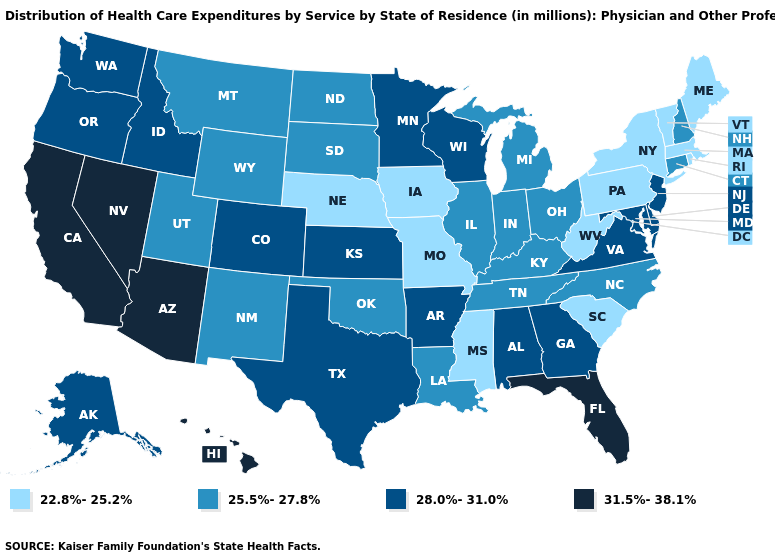Which states have the highest value in the USA?
Quick response, please. Arizona, California, Florida, Hawaii, Nevada. Does New Mexico have a higher value than Oklahoma?
Short answer required. No. What is the value of Oklahoma?
Answer briefly. 25.5%-27.8%. Does Pennsylvania have the highest value in the USA?
Answer briefly. No. Name the states that have a value in the range 22.8%-25.2%?
Short answer required. Iowa, Maine, Massachusetts, Mississippi, Missouri, Nebraska, New York, Pennsylvania, Rhode Island, South Carolina, Vermont, West Virginia. What is the value of Washington?
Keep it brief. 28.0%-31.0%. Among the states that border Minnesota , which have the lowest value?
Be succinct. Iowa. Name the states that have a value in the range 31.5%-38.1%?
Quick response, please. Arizona, California, Florida, Hawaii, Nevada. What is the value of Illinois?
Keep it brief. 25.5%-27.8%. Name the states that have a value in the range 25.5%-27.8%?
Keep it brief. Connecticut, Illinois, Indiana, Kentucky, Louisiana, Michigan, Montana, New Hampshire, New Mexico, North Carolina, North Dakota, Ohio, Oklahoma, South Dakota, Tennessee, Utah, Wyoming. What is the highest value in the USA?
Concise answer only. 31.5%-38.1%. What is the value of Texas?
Quick response, please. 28.0%-31.0%. Does the first symbol in the legend represent the smallest category?
Quick response, please. Yes. Does Alabama have a lower value than Nevada?
Give a very brief answer. Yes. What is the value of New York?
Concise answer only. 22.8%-25.2%. 